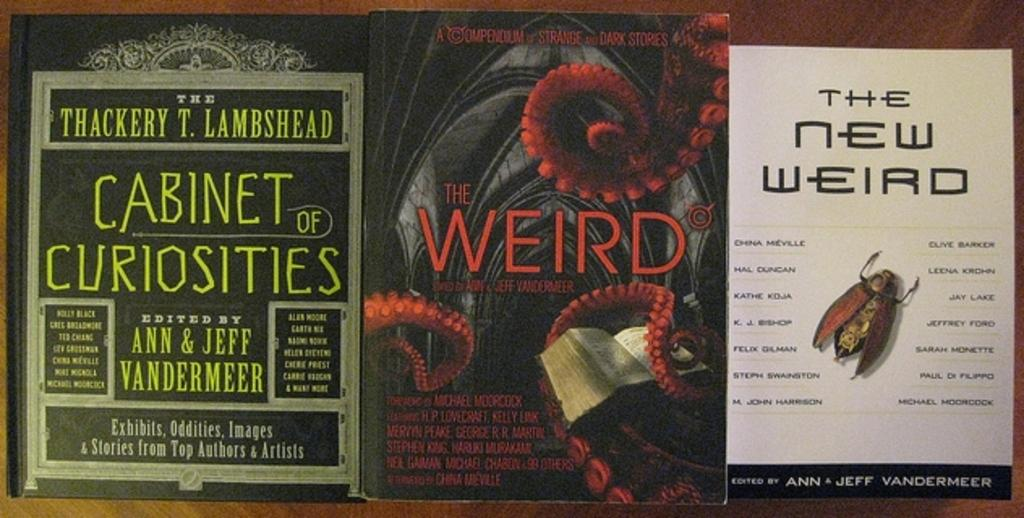<image>
Present a compact description of the photo's key features. An ad is open with an article titled The New Weird on the right side. 